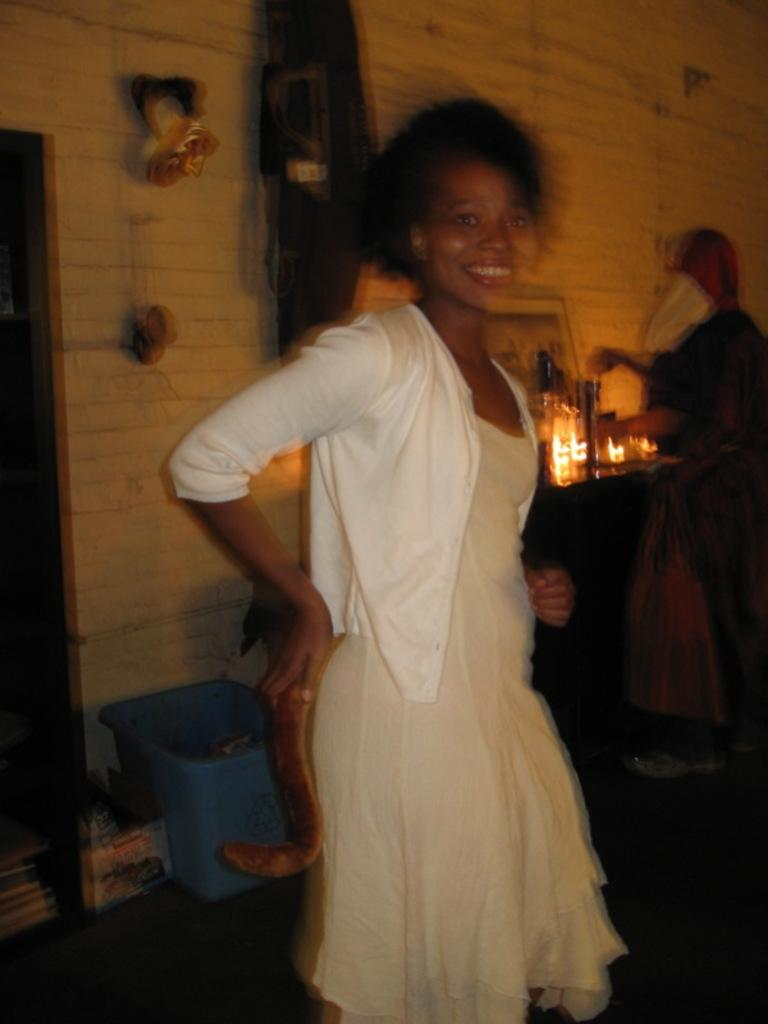What is the woman doing in the image? The woman is standing in the middle of the room. What can be seen behind the woman? There is a wall behind the woman. What is the purpose of the object visible in the image? The dustbin is visible in the image, which is typically used for disposing of waste. Can you describe any other objects or features in the room? There are other unspecified things present in the room, but their details are not provided. How many crows are sitting on the plants in the image? There are no crows or plants present in the image. 